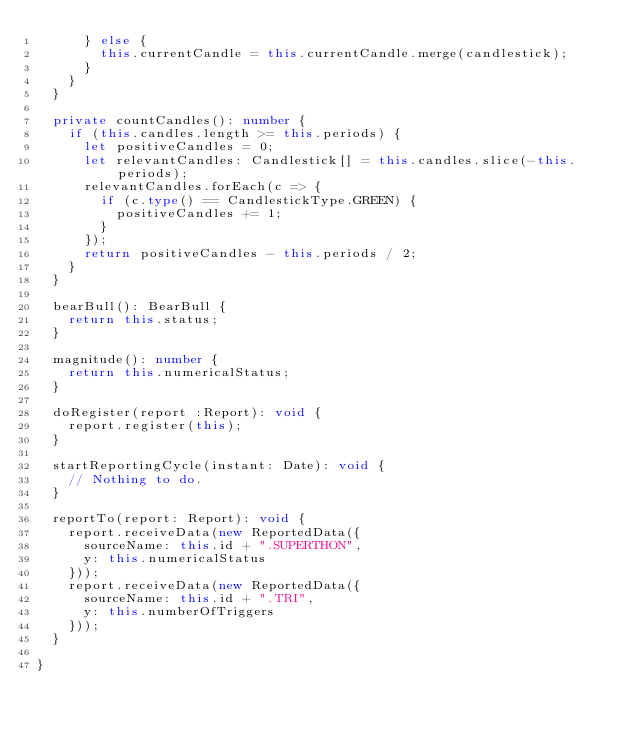<code> <loc_0><loc_0><loc_500><loc_500><_TypeScript_>      } else {
        this.currentCandle = this.currentCandle.merge(candlestick);
      }
    }
  }

  private countCandles(): number {
    if (this.candles.length >= this.periods) {
      let positiveCandles = 0;
      let relevantCandles: Candlestick[] = this.candles.slice(-this.periods);
      relevantCandles.forEach(c => {
        if (c.type() == CandlestickType.GREEN) {
          positiveCandles += 1;
        }
      });
      return positiveCandles - this.periods / 2;
    }
  }

  bearBull(): BearBull {
    return this.status;
  }

  magnitude(): number {
    return this.numericalStatus;
  }

  doRegister(report :Report): void {
    report.register(this);
  }

  startReportingCycle(instant: Date): void {
    // Nothing to do.
  }

  reportTo(report: Report): void {
    report.receiveData(new ReportedData({
      sourceName: this.id + ".SUPERTHON",
      y: this.numericalStatus
    }));
    report.receiveData(new ReportedData({
      sourceName: this.id + ".TRI",
      y: this.numberOfTriggers
    }));
  }

}
</code> 